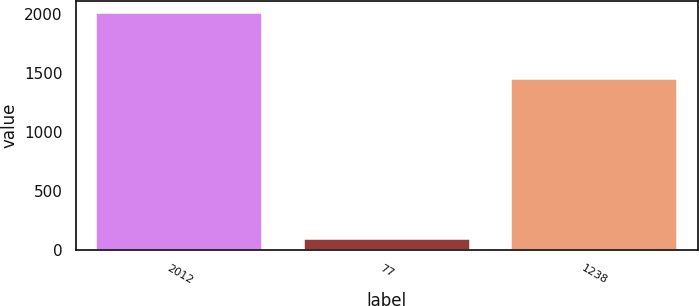<chart> <loc_0><loc_0><loc_500><loc_500><bar_chart><fcel>2012<fcel>77<fcel>1238<nl><fcel>2011<fcel>97<fcel>1447<nl></chart> 